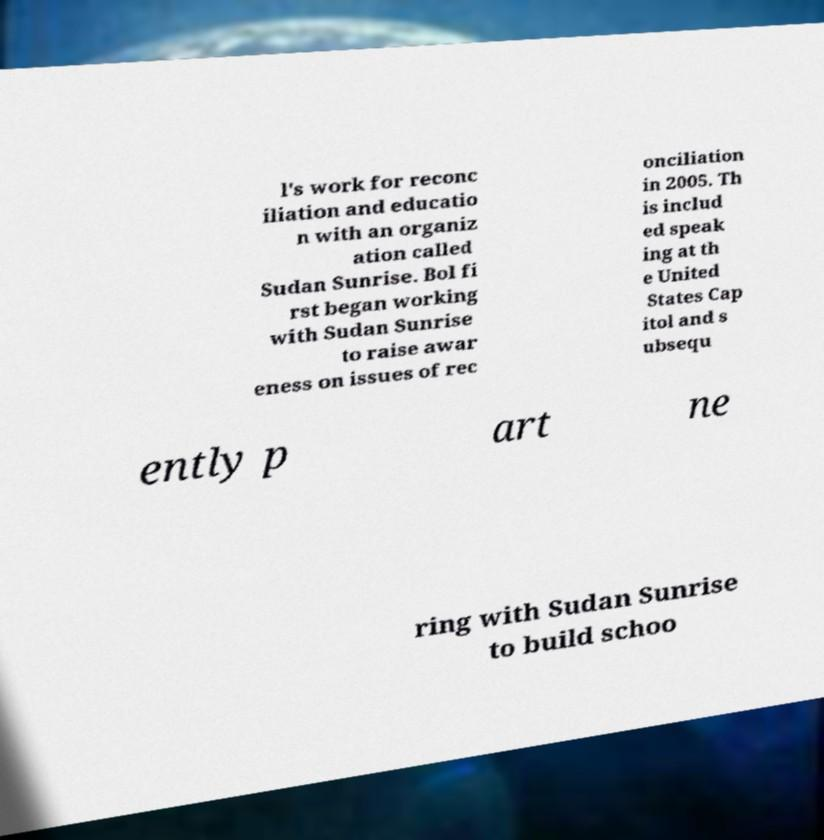I need the written content from this picture converted into text. Can you do that? l's work for reconc iliation and educatio n with an organiz ation called Sudan Sunrise. Bol fi rst began working with Sudan Sunrise to raise awar eness on issues of rec onciliation in 2005. Th is includ ed speak ing at th e United States Cap itol and s ubsequ ently p art ne ring with Sudan Sunrise to build schoo 